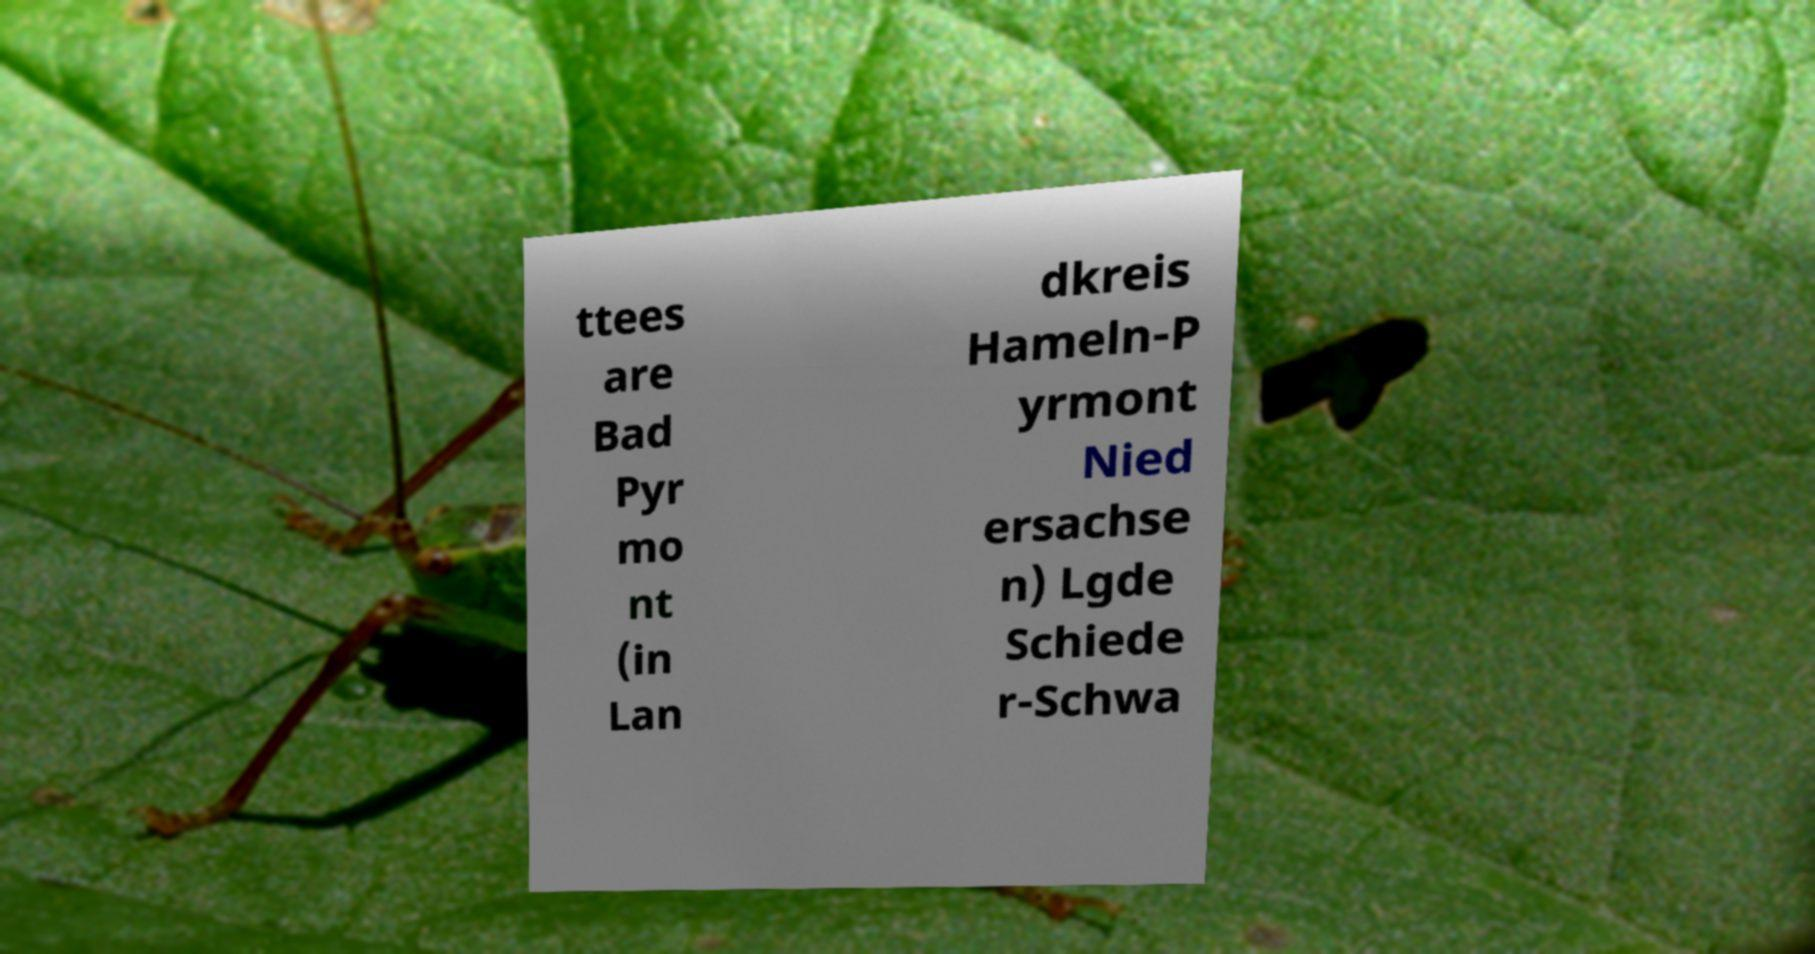For documentation purposes, I need the text within this image transcribed. Could you provide that? ttees are Bad Pyr mo nt (in Lan dkreis Hameln-P yrmont Nied ersachse n) Lgde Schiede r-Schwa 